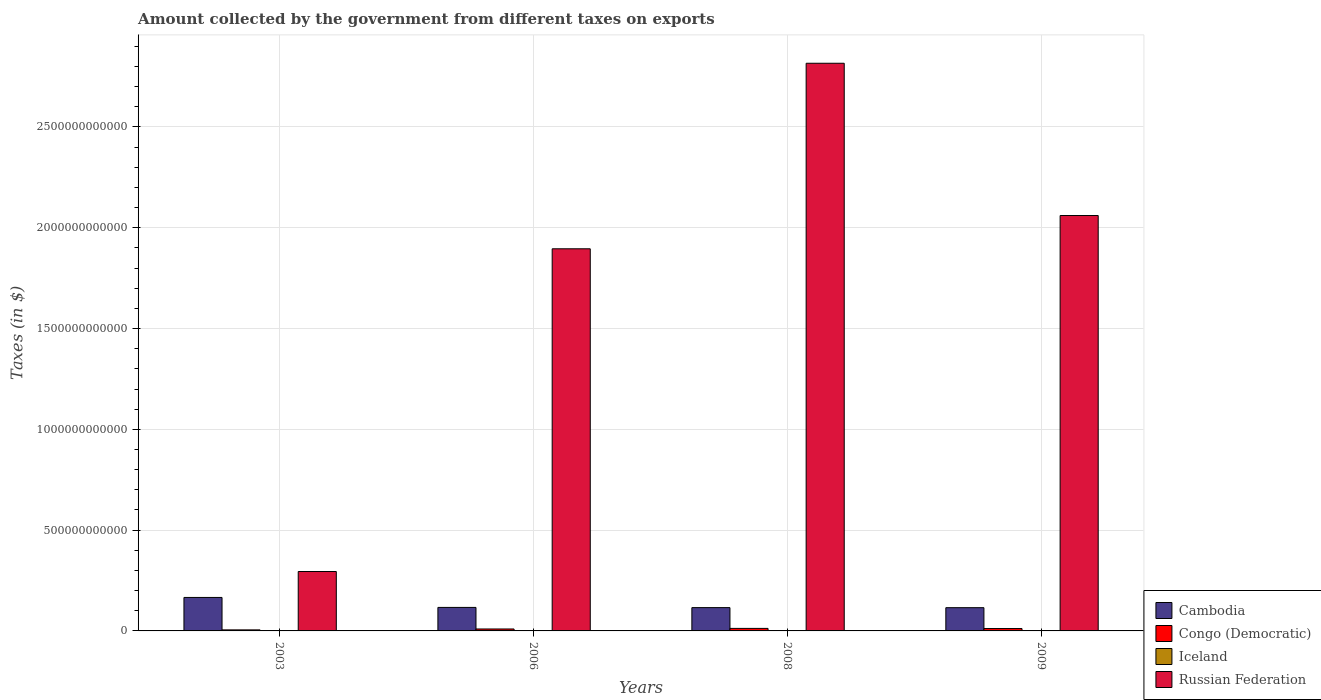How many different coloured bars are there?
Your answer should be compact. 4. How many bars are there on the 4th tick from the left?
Your answer should be compact. 4. How many bars are there on the 1st tick from the right?
Offer a terse response. 4. What is the amount collected by the government from taxes on exports in Russian Federation in 2008?
Give a very brief answer. 2.82e+12. Across all years, what is the maximum amount collected by the government from taxes on exports in Congo (Democratic)?
Offer a terse response. 1.25e+1. Across all years, what is the minimum amount collected by the government from taxes on exports in Cambodia?
Make the answer very short. 1.15e+11. In which year was the amount collected by the government from taxes on exports in Congo (Democratic) minimum?
Provide a succinct answer. 2003. What is the total amount collected by the government from taxes on exports in Congo (Democratic) in the graph?
Ensure brevity in your answer.  3.91e+1. What is the difference between the amount collected by the government from taxes on exports in Russian Federation in 2003 and that in 2008?
Make the answer very short. -2.52e+12. What is the difference between the amount collected by the government from taxes on exports in Cambodia in 2008 and the amount collected by the government from taxes on exports in Iceland in 2003?
Make the answer very short. 1.16e+11. What is the average amount collected by the government from taxes on exports in Cambodia per year?
Offer a terse response. 1.28e+11. In the year 2006, what is the difference between the amount collected by the government from taxes on exports in Iceland and amount collected by the government from taxes on exports in Congo (Democratic)?
Offer a very short reply. -9.63e+09. In how many years, is the amount collected by the government from taxes on exports in Russian Federation greater than 200000000000 $?
Keep it short and to the point. 4. What is the ratio of the amount collected by the government from taxes on exports in Cambodia in 2003 to that in 2009?
Your response must be concise. 1.44. What is the difference between the highest and the second highest amount collected by the government from taxes on exports in Iceland?
Provide a succinct answer. 8.44e+05. What is the difference between the highest and the lowest amount collected by the government from taxes on exports in Russian Federation?
Give a very brief answer. 2.52e+12. Is the sum of the amount collected by the government from taxes on exports in Cambodia in 2006 and 2008 greater than the maximum amount collected by the government from taxes on exports in Congo (Democratic) across all years?
Provide a succinct answer. Yes. What does the 1st bar from the left in 2008 represents?
Provide a succinct answer. Cambodia. What does the 2nd bar from the right in 2009 represents?
Provide a succinct answer. Iceland. How many bars are there?
Provide a short and direct response. 16. Are all the bars in the graph horizontal?
Keep it short and to the point. No. What is the difference between two consecutive major ticks on the Y-axis?
Give a very brief answer. 5.00e+11. Are the values on the major ticks of Y-axis written in scientific E-notation?
Your answer should be compact. No. How are the legend labels stacked?
Offer a very short reply. Vertical. What is the title of the graph?
Your answer should be very brief. Amount collected by the government from different taxes on exports. What is the label or title of the X-axis?
Keep it short and to the point. Years. What is the label or title of the Y-axis?
Make the answer very short. Taxes (in $). What is the Taxes (in $) in Cambodia in 2003?
Offer a very short reply. 1.66e+11. What is the Taxes (in $) in Congo (Democratic) in 2003?
Offer a very short reply. 5.12e+09. What is the Taxes (in $) in Iceland in 2003?
Provide a succinct answer. 7.25e+05. What is the Taxes (in $) in Russian Federation in 2003?
Ensure brevity in your answer.  2.95e+11. What is the Taxes (in $) in Cambodia in 2006?
Make the answer very short. 1.17e+11. What is the Taxes (in $) in Congo (Democratic) in 2006?
Give a very brief answer. 9.63e+09. What is the Taxes (in $) of Iceland in 2006?
Provide a short and direct response. 3.10e+06. What is the Taxes (in $) in Russian Federation in 2006?
Make the answer very short. 1.90e+12. What is the Taxes (in $) of Cambodia in 2008?
Provide a short and direct response. 1.16e+11. What is the Taxes (in $) in Congo (Democratic) in 2008?
Offer a terse response. 1.25e+1. What is the Taxes (in $) in Iceland in 2008?
Offer a terse response. 6.26e+06. What is the Taxes (in $) in Russian Federation in 2008?
Your answer should be very brief. 2.82e+12. What is the Taxes (in $) of Cambodia in 2009?
Offer a terse response. 1.15e+11. What is the Taxes (in $) of Congo (Democratic) in 2009?
Your answer should be very brief. 1.18e+1. What is the Taxes (in $) of Iceland in 2009?
Offer a very short reply. 5.41e+06. What is the Taxes (in $) in Russian Federation in 2009?
Your response must be concise. 2.06e+12. Across all years, what is the maximum Taxes (in $) of Cambodia?
Your answer should be very brief. 1.66e+11. Across all years, what is the maximum Taxes (in $) in Congo (Democratic)?
Offer a very short reply. 1.25e+1. Across all years, what is the maximum Taxes (in $) in Iceland?
Provide a short and direct response. 6.26e+06. Across all years, what is the maximum Taxes (in $) in Russian Federation?
Make the answer very short. 2.82e+12. Across all years, what is the minimum Taxes (in $) of Cambodia?
Provide a succinct answer. 1.15e+11. Across all years, what is the minimum Taxes (in $) in Congo (Democratic)?
Keep it short and to the point. 5.12e+09. Across all years, what is the minimum Taxes (in $) in Iceland?
Make the answer very short. 7.25e+05. Across all years, what is the minimum Taxes (in $) in Russian Federation?
Give a very brief answer. 2.95e+11. What is the total Taxes (in $) in Cambodia in the graph?
Provide a succinct answer. 5.14e+11. What is the total Taxes (in $) in Congo (Democratic) in the graph?
Keep it short and to the point. 3.91e+1. What is the total Taxes (in $) of Iceland in the graph?
Ensure brevity in your answer.  1.55e+07. What is the total Taxes (in $) in Russian Federation in the graph?
Provide a short and direct response. 7.07e+12. What is the difference between the Taxes (in $) in Cambodia in 2003 and that in 2006?
Your response must be concise. 4.94e+1. What is the difference between the Taxes (in $) of Congo (Democratic) in 2003 and that in 2006?
Keep it short and to the point. -4.51e+09. What is the difference between the Taxes (in $) of Iceland in 2003 and that in 2006?
Your response must be concise. -2.38e+06. What is the difference between the Taxes (in $) in Russian Federation in 2003 and that in 2006?
Offer a terse response. -1.60e+12. What is the difference between the Taxes (in $) of Cambodia in 2003 and that in 2008?
Provide a short and direct response. 5.04e+1. What is the difference between the Taxes (in $) of Congo (Democratic) in 2003 and that in 2008?
Ensure brevity in your answer.  -7.38e+09. What is the difference between the Taxes (in $) in Iceland in 2003 and that in 2008?
Offer a terse response. -5.53e+06. What is the difference between the Taxes (in $) of Russian Federation in 2003 and that in 2008?
Your answer should be compact. -2.52e+12. What is the difference between the Taxes (in $) in Cambodia in 2003 and that in 2009?
Give a very brief answer. 5.07e+1. What is the difference between the Taxes (in $) in Congo (Democratic) in 2003 and that in 2009?
Offer a terse response. -6.71e+09. What is the difference between the Taxes (in $) of Iceland in 2003 and that in 2009?
Provide a succinct answer. -4.69e+06. What is the difference between the Taxes (in $) in Russian Federation in 2003 and that in 2009?
Offer a terse response. -1.77e+12. What is the difference between the Taxes (in $) in Cambodia in 2006 and that in 2008?
Your answer should be compact. 1.02e+09. What is the difference between the Taxes (in $) of Congo (Democratic) in 2006 and that in 2008?
Your answer should be compact. -2.87e+09. What is the difference between the Taxes (in $) of Iceland in 2006 and that in 2008?
Give a very brief answer. -3.16e+06. What is the difference between the Taxes (in $) of Russian Federation in 2006 and that in 2008?
Offer a very short reply. -9.20e+11. What is the difference between the Taxes (in $) in Cambodia in 2006 and that in 2009?
Keep it short and to the point. 1.31e+09. What is the difference between the Taxes (in $) of Congo (Democratic) in 2006 and that in 2009?
Your response must be concise. -2.20e+09. What is the difference between the Taxes (in $) of Iceland in 2006 and that in 2009?
Provide a succinct answer. -2.31e+06. What is the difference between the Taxes (in $) of Russian Federation in 2006 and that in 2009?
Keep it short and to the point. -1.65e+11. What is the difference between the Taxes (in $) in Cambodia in 2008 and that in 2009?
Provide a succinct answer. 2.95e+08. What is the difference between the Taxes (in $) of Congo (Democratic) in 2008 and that in 2009?
Your answer should be compact. 6.64e+08. What is the difference between the Taxes (in $) of Iceland in 2008 and that in 2009?
Keep it short and to the point. 8.44e+05. What is the difference between the Taxes (in $) in Russian Federation in 2008 and that in 2009?
Provide a succinct answer. 7.55e+11. What is the difference between the Taxes (in $) in Cambodia in 2003 and the Taxes (in $) in Congo (Democratic) in 2006?
Your answer should be compact. 1.56e+11. What is the difference between the Taxes (in $) of Cambodia in 2003 and the Taxes (in $) of Iceland in 2006?
Ensure brevity in your answer.  1.66e+11. What is the difference between the Taxes (in $) in Cambodia in 2003 and the Taxes (in $) in Russian Federation in 2006?
Offer a very short reply. -1.73e+12. What is the difference between the Taxes (in $) in Congo (Democratic) in 2003 and the Taxes (in $) in Iceland in 2006?
Offer a very short reply. 5.12e+09. What is the difference between the Taxes (in $) of Congo (Democratic) in 2003 and the Taxes (in $) of Russian Federation in 2006?
Make the answer very short. -1.89e+12. What is the difference between the Taxes (in $) in Iceland in 2003 and the Taxes (in $) in Russian Federation in 2006?
Make the answer very short. -1.90e+12. What is the difference between the Taxes (in $) of Cambodia in 2003 and the Taxes (in $) of Congo (Democratic) in 2008?
Provide a short and direct response. 1.54e+11. What is the difference between the Taxes (in $) of Cambodia in 2003 and the Taxes (in $) of Iceland in 2008?
Your answer should be very brief. 1.66e+11. What is the difference between the Taxes (in $) of Cambodia in 2003 and the Taxes (in $) of Russian Federation in 2008?
Provide a succinct answer. -2.65e+12. What is the difference between the Taxes (in $) of Congo (Democratic) in 2003 and the Taxes (in $) of Iceland in 2008?
Provide a succinct answer. 5.11e+09. What is the difference between the Taxes (in $) in Congo (Democratic) in 2003 and the Taxes (in $) in Russian Federation in 2008?
Your response must be concise. -2.81e+12. What is the difference between the Taxes (in $) of Iceland in 2003 and the Taxes (in $) of Russian Federation in 2008?
Offer a very short reply. -2.82e+12. What is the difference between the Taxes (in $) of Cambodia in 2003 and the Taxes (in $) of Congo (Democratic) in 2009?
Keep it short and to the point. 1.54e+11. What is the difference between the Taxes (in $) in Cambodia in 2003 and the Taxes (in $) in Iceland in 2009?
Your answer should be compact. 1.66e+11. What is the difference between the Taxes (in $) in Cambodia in 2003 and the Taxes (in $) in Russian Federation in 2009?
Keep it short and to the point. -1.89e+12. What is the difference between the Taxes (in $) of Congo (Democratic) in 2003 and the Taxes (in $) of Iceland in 2009?
Give a very brief answer. 5.11e+09. What is the difference between the Taxes (in $) of Congo (Democratic) in 2003 and the Taxes (in $) of Russian Federation in 2009?
Offer a very short reply. -2.06e+12. What is the difference between the Taxes (in $) in Iceland in 2003 and the Taxes (in $) in Russian Federation in 2009?
Keep it short and to the point. -2.06e+12. What is the difference between the Taxes (in $) of Cambodia in 2006 and the Taxes (in $) of Congo (Democratic) in 2008?
Give a very brief answer. 1.04e+11. What is the difference between the Taxes (in $) of Cambodia in 2006 and the Taxes (in $) of Iceland in 2008?
Your response must be concise. 1.17e+11. What is the difference between the Taxes (in $) of Cambodia in 2006 and the Taxes (in $) of Russian Federation in 2008?
Provide a short and direct response. -2.70e+12. What is the difference between the Taxes (in $) of Congo (Democratic) in 2006 and the Taxes (in $) of Iceland in 2008?
Provide a short and direct response. 9.62e+09. What is the difference between the Taxes (in $) of Congo (Democratic) in 2006 and the Taxes (in $) of Russian Federation in 2008?
Make the answer very short. -2.81e+12. What is the difference between the Taxes (in $) in Iceland in 2006 and the Taxes (in $) in Russian Federation in 2008?
Give a very brief answer. -2.82e+12. What is the difference between the Taxes (in $) of Cambodia in 2006 and the Taxes (in $) of Congo (Democratic) in 2009?
Give a very brief answer. 1.05e+11. What is the difference between the Taxes (in $) of Cambodia in 2006 and the Taxes (in $) of Iceland in 2009?
Give a very brief answer. 1.17e+11. What is the difference between the Taxes (in $) of Cambodia in 2006 and the Taxes (in $) of Russian Federation in 2009?
Make the answer very short. -1.94e+12. What is the difference between the Taxes (in $) of Congo (Democratic) in 2006 and the Taxes (in $) of Iceland in 2009?
Provide a short and direct response. 9.63e+09. What is the difference between the Taxes (in $) of Congo (Democratic) in 2006 and the Taxes (in $) of Russian Federation in 2009?
Offer a terse response. -2.05e+12. What is the difference between the Taxes (in $) of Iceland in 2006 and the Taxes (in $) of Russian Federation in 2009?
Ensure brevity in your answer.  -2.06e+12. What is the difference between the Taxes (in $) of Cambodia in 2008 and the Taxes (in $) of Congo (Democratic) in 2009?
Ensure brevity in your answer.  1.04e+11. What is the difference between the Taxes (in $) in Cambodia in 2008 and the Taxes (in $) in Iceland in 2009?
Provide a short and direct response. 1.16e+11. What is the difference between the Taxes (in $) of Cambodia in 2008 and the Taxes (in $) of Russian Federation in 2009?
Ensure brevity in your answer.  -1.95e+12. What is the difference between the Taxes (in $) of Congo (Democratic) in 2008 and the Taxes (in $) of Iceland in 2009?
Offer a very short reply. 1.25e+1. What is the difference between the Taxes (in $) of Congo (Democratic) in 2008 and the Taxes (in $) of Russian Federation in 2009?
Offer a terse response. -2.05e+12. What is the difference between the Taxes (in $) in Iceland in 2008 and the Taxes (in $) in Russian Federation in 2009?
Make the answer very short. -2.06e+12. What is the average Taxes (in $) of Cambodia per year?
Your answer should be very brief. 1.28e+11. What is the average Taxes (in $) of Congo (Democratic) per year?
Provide a short and direct response. 9.77e+09. What is the average Taxes (in $) in Iceland per year?
Provide a succinct answer. 3.87e+06. What is the average Taxes (in $) of Russian Federation per year?
Keep it short and to the point. 1.77e+12. In the year 2003, what is the difference between the Taxes (in $) in Cambodia and Taxes (in $) in Congo (Democratic)?
Ensure brevity in your answer.  1.61e+11. In the year 2003, what is the difference between the Taxes (in $) of Cambodia and Taxes (in $) of Iceland?
Give a very brief answer. 1.66e+11. In the year 2003, what is the difference between the Taxes (in $) in Cambodia and Taxes (in $) in Russian Federation?
Offer a very short reply. -1.29e+11. In the year 2003, what is the difference between the Taxes (in $) in Congo (Democratic) and Taxes (in $) in Iceland?
Offer a very short reply. 5.12e+09. In the year 2003, what is the difference between the Taxes (in $) of Congo (Democratic) and Taxes (in $) of Russian Federation?
Ensure brevity in your answer.  -2.90e+11. In the year 2003, what is the difference between the Taxes (in $) of Iceland and Taxes (in $) of Russian Federation?
Provide a succinct answer. -2.95e+11. In the year 2006, what is the difference between the Taxes (in $) in Cambodia and Taxes (in $) in Congo (Democratic)?
Your answer should be very brief. 1.07e+11. In the year 2006, what is the difference between the Taxes (in $) of Cambodia and Taxes (in $) of Iceland?
Offer a terse response. 1.17e+11. In the year 2006, what is the difference between the Taxes (in $) of Cambodia and Taxes (in $) of Russian Federation?
Make the answer very short. -1.78e+12. In the year 2006, what is the difference between the Taxes (in $) in Congo (Democratic) and Taxes (in $) in Iceland?
Keep it short and to the point. 9.63e+09. In the year 2006, what is the difference between the Taxes (in $) in Congo (Democratic) and Taxes (in $) in Russian Federation?
Provide a short and direct response. -1.89e+12. In the year 2006, what is the difference between the Taxes (in $) of Iceland and Taxes (in $) of Russian Federation?
Your answer should be very brief. -1.90e+12. In the year 2008, what is the difference between the Taxes (in $) in Cambodia and Taxes (in $) in Congo (Democratic)?
Offer a very short reply. 1.03e+11. In the year 2008, what is the difference between the Taxes (in $) of Cambodia and Taxes (in $) of Iceland?
Offer a very short reply. 1.16e+11. In the year 2008, what is the difference between the Taxes (in $) of Cambodia and Taxes (in $) of Russian Federation?
Offer a terse response. -2.70e+12. In the year 2008, what is the difference between the Taxes (in $) of Congo (Democratic) and Taxes (in $) of Iceland?
Make the answer very short. 1.25e+1. In the year 2008, what is the difference between the Taxes (in $) in Congo (Democratic) and Taxes (in $) in Russian Federation?
Your response must be concise. -2.80e+12. In the year 2008, what is the difference between the Taxes (in $) in Iceland and Taxes (in $) in Russian Federation?
Ensure brevity in your answer.  -2.82e+12. In the year 2009, what is the difference between the Taxes (in $) in Cambodia and Taxes (in $) in Congo (Democratic)?
Your answer should be very brief. 1.03e+11. In the year 2009, what is the difference between the Taxes (in $) in Cambodia and Taxes (in $) in Iceland?
Offer a terse response. 1.15e+11. In the year 2009, what is the difference between the Taxes (in $) of Cambodia and Taxes (in $) of Russian Federation?
Your response must be concise. -1.95e+12. In the year 2009, what is the difference between the Taxes (in $) of Congo (Democratic) and Taxes (in $) of Iceland?
Your answer should be very brief. 1.18e+1. In the year 2009, what is the difference between the Taxes (in $) in Congo (Democratic) and Taxes (in $) in Russian Federation?
Offer a terse response. -2.05e+12. In the year 2009, what is the difference between the Taxes (in $) in Iceland and Taxes (in $) in Russian Federation?
Provide a succinct answer. -2.06e+12. What is the ratio of the Taxes (in $) in Cambodia in 2003 to that in 2006?
Ensure brevity in your answer.  1.42. What is the ratio of the Taxes (in $) of Congo (Democratic) in 2003 to that in 2006?
Your response must be concise. 0.53. What is the ratio of the Taxes (in $) of Iceland in 2003 to that in 2006?
Your response must be concise. 0.23. What is the ratio of the Taxes (in $) in Russian Federation in 2003 to that in 2006?
Give a very brief answer. 0.16. What is the ratio of the Taxes (in $) in Cambodia in 2003 to that in 2008?
Your response must be concise. 1.44. What is the ratio of the Taxes (in $) of Congo (Democratic) in 2003 to that in 2008?
Offer a terse response. 0.41. What is the ratio of the Taxes (in $) of Iceland in 2003 to that in 2008?
Offer a terse response. 0.12. What is the ratio of the Taxes (in $) of Russian Federation in 2003 to that in 2008?
Provide a short and direct response. 0.1. What is the ratio of the Taxes (in $) in Cambodia in 2003 to that in 2009?
Give a very brief answer. 1.44. What is the ratio of the Taxes (in $) in Congo (Democratic) in 2003 to that in 2009?
Give a very brief answer. 0.43. What is the ratio of the Taxes (in $) in Iceland in 2003 to that in 2009?
Offer a terse response. 0.13. What is the ratio of the Taxes (in $) of Russian Federation in 2003 to that in 2009?
Offer a very short reply. 0.14. What is the ratio of the Taxes (in $) in Cambodia in 2006 to that in 2008?
Provide a succinct answer. 1.01. What is the ratio of the Taxes (in $) in Congo (Democratic) in 2006 to that in 2008?
Make the answer very short. 0.77. What is the ratio of the Taxes (in $) of Iceland in 2006 to that in 2008?
Your answer should be compact. 0.5. What is the ratio of the Taxes (in $) of Russian Federation in 2006 to that in 2008?
Provide a short and direct response. 0.67. What is the ratio of the Taxes (in $) in Cambodia in 2006 to that in 2009?
Provide a succinct answer. 1.01. What is the ratio of the Taxes (in $) in Congo (Democratic) in 2006 to that in 2009?
Keep it short and to the point. 0.81. What is the ratio of the Taxes (in $) of Iceland in 2006 to that in 2009?
Ensure brevity in your answer.  0.57. What is the ratio of the Taxes (in $) in Russian Federation in 2006 to that in 2009?
Give a very brief answer. 0.92. What is the ratio of the Taxes (in $) in Congo (Democratic) in 2008 to that in 2009?
Your answer should be compact. 1.06. What is the ratio of the Taxes (in $) of Iceland in 2008 to that in 2009?
Keep it short and to the point. 1.16. What is the ratio of the Taxes (in $) of Russian Federation in 2008 to that in 2009?
Give a very brief answer. 1.37. What is the difference between the highest and the second highest Taxes (in $) in Cambodia?
Make the answer very short. 4.94e+1. What is the difference between the highest and the second highest Taxes (in $) in Congo (Democratic)?
Provide a short and direct response. 6.64e+08. What is the difference between the highest and the second highest Taxes (in $) in Iceland?
Give a very brief answer. 8.44e+05. What is the difference between the highest and the second highest Taxes (in $) in Russian Federation?
Offer a terse response. 7.55e+11. What is the difference between the highest and the lowest Taxes (in $) of Cambodia?
Ensure brevity in your answer.  5.07e+1. What is the difference between the highest and the lowest Taxes (in $) of Congo (Democratic)?
Provide a succinct answer. 7.38e+09. What is the difference between the highest and the lowest Taxes (in $) in Iceland?
Your response must be concise. 5.53e+06. What is the difference between the highest and the lowest Taxes (in $) of Russian Federation?
Your answer should be very brief. 2.52e+12. 